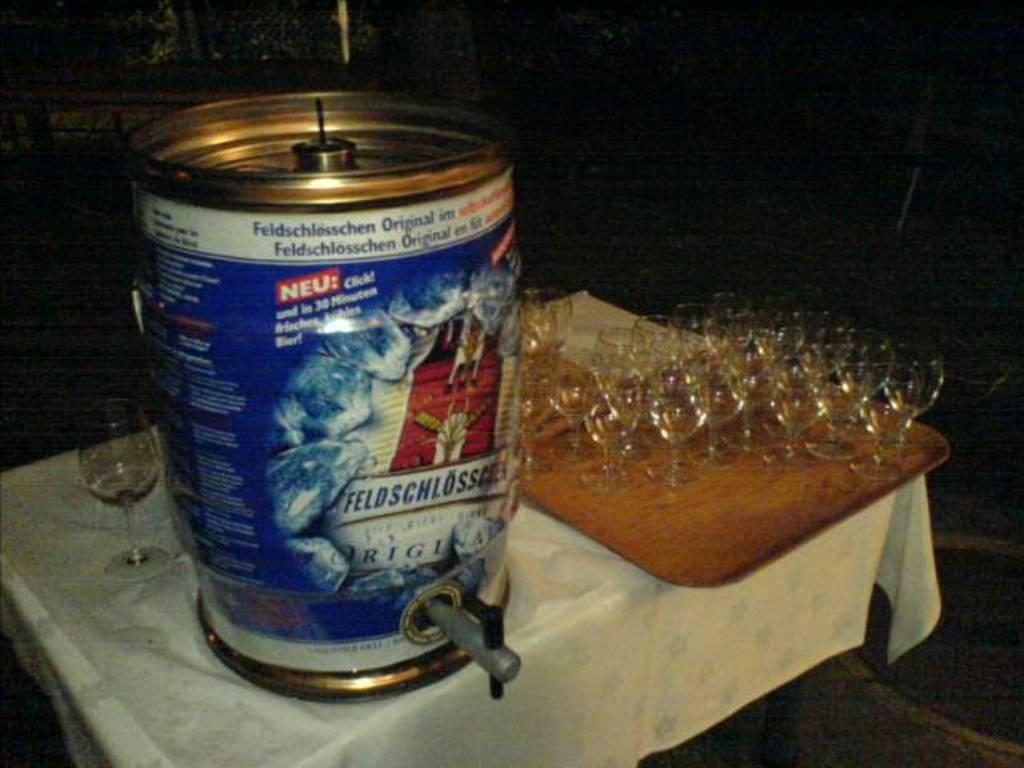<image>
Render a clear and concise summary of the photo. Can on top of a table that says "NEU" in red. 